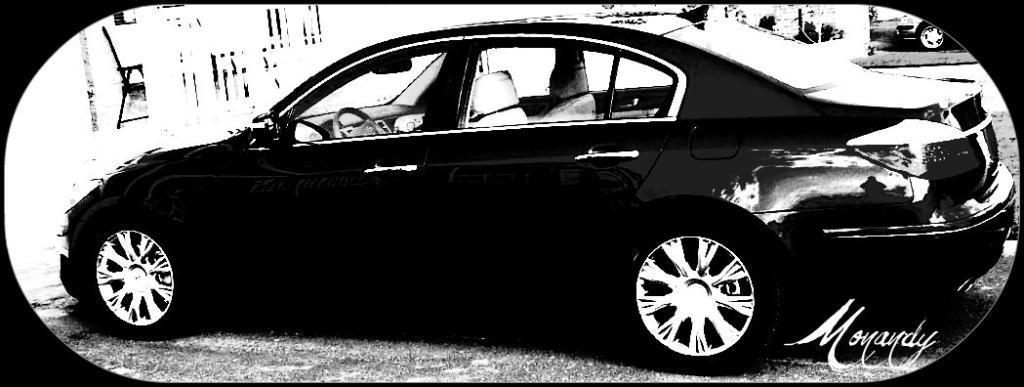Please provide a concise description of this image. In this image I can see a car. At the bottom right there is some text on it. This the black and white image. 